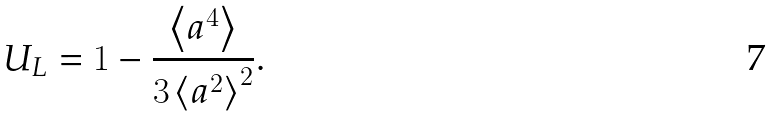Convert formula to latex. <formula><loc_0><loc_0><loc_500><loc_500>U _ { L } = 1 - \frac { \left < a ^ { 4 } \right > } { 3 \left < a ^ { 2 } \right > ^ { 2 } } .</formula> 